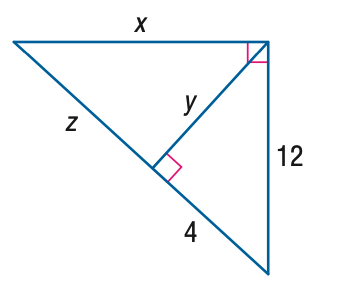Answer the mathemtical geometry problem and directly provide the correct option letter.
Question: Find y.
Choices: A: 8 B: 8 \sqrt { 2 } C: 12 D: 8 \sqrt { 3 } B 